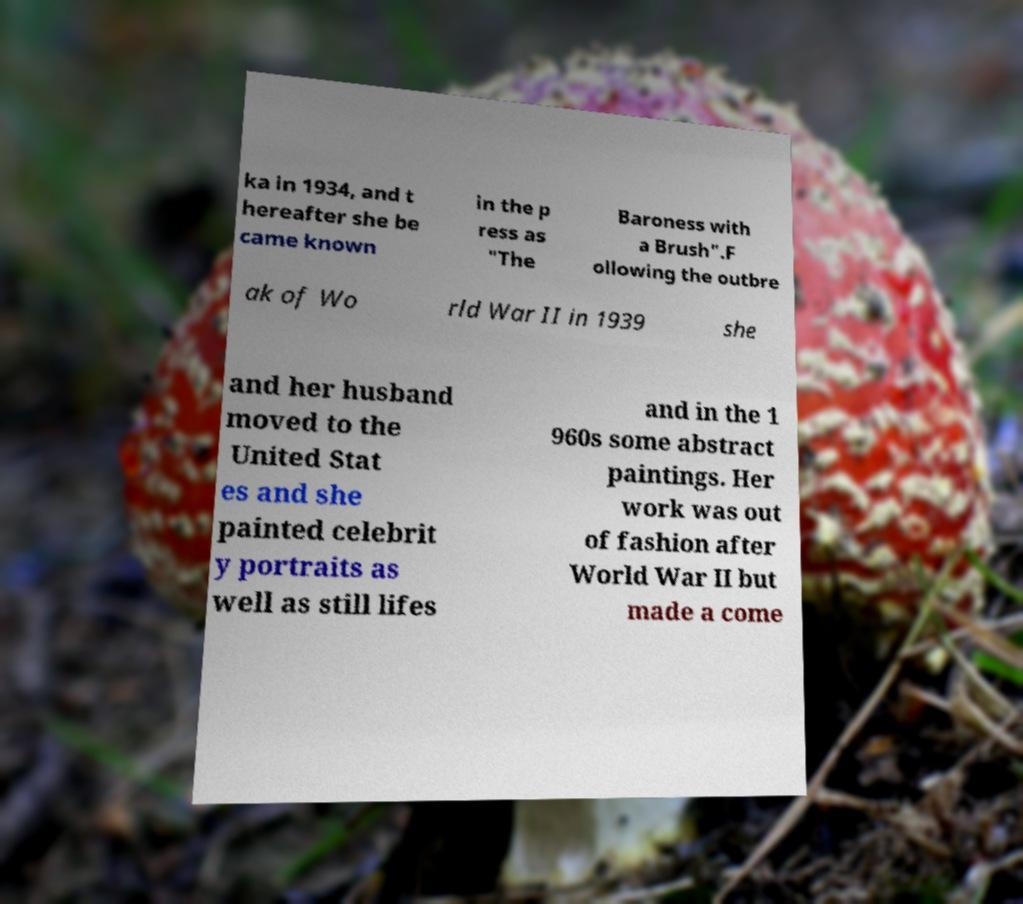I need the written content from this picture converted into text. Can you do that? ka in 1934, and t hereafter she be came known in the p ress as "The Baroness with a Brush".F ollowing the outbre ak of Wo rld War II in 1939 she and her husband moved to the United Stat es and she painted celebrit y portraits as well as still lifes and in the 1 960s some abstract paintings. Her work was out of fashion after World War II but made a come 